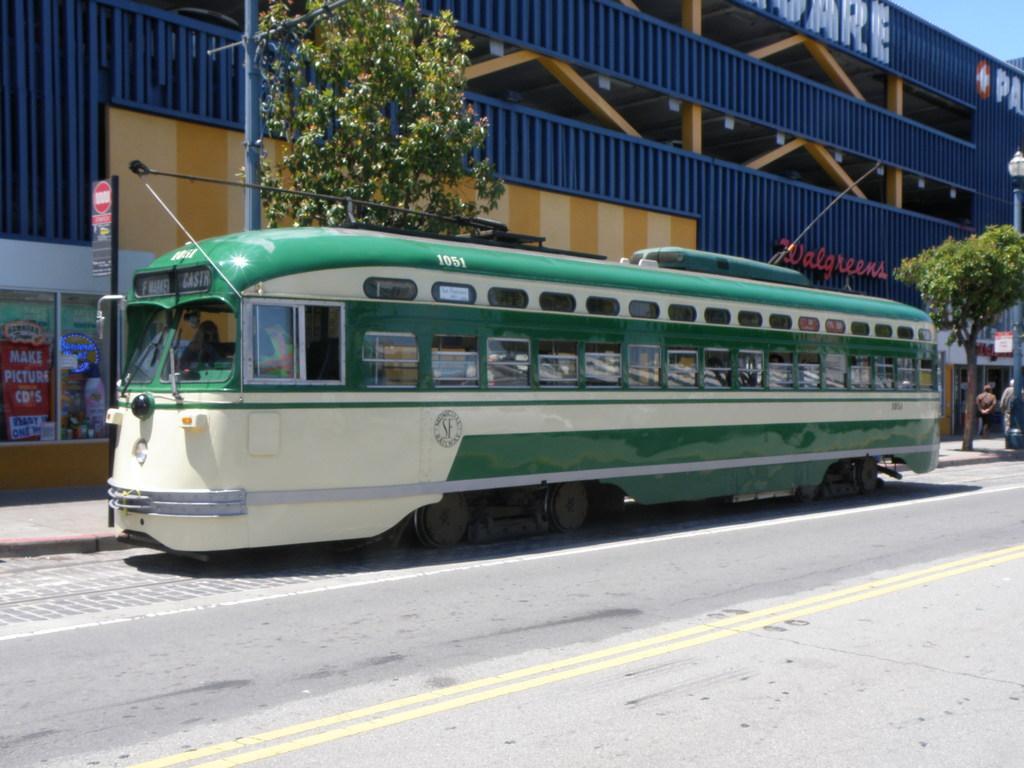Please provide a concise description of this image. In this picture I can see the road in front, on which I can see a public transport and in the background I can see a building, few trees and light poles and on the right side of this picture I can see 2 persons and I see something is written on the building. 